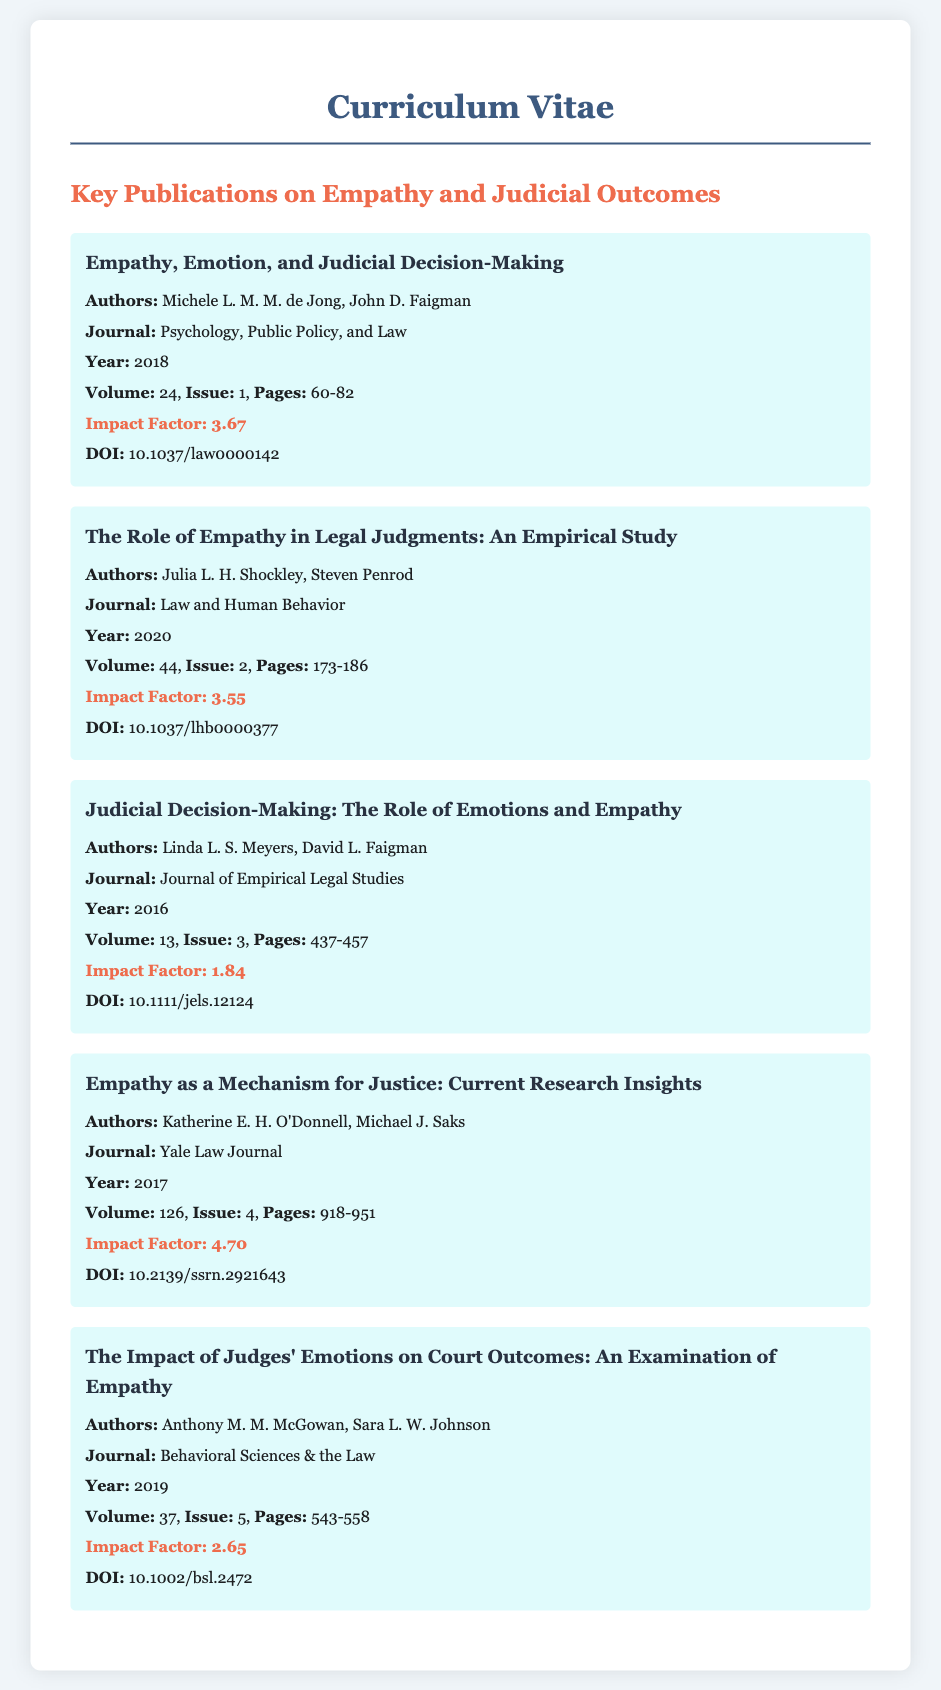What is the title of the first publication listed? The title of the first publication is given in the document under "Key Publications on Empathy and Judicial Outcomes."
Answer: Empathy, Emotion, and Judicial Decision-Making Who are the authors of "The Role of Empathy in Legal Judgments: An Empirical Study"? The authors are listed directly under the title of the publication, providing the necessary details.
Answer: Julia L. H. Shockley, Steven Penrod What is the impact factor of the publication "Empathy as a Mechanism for Justice: Current Research Insights"? The impact factor is highlighted in the document, making it easy to retrieve this specific data.
Answer: 4.70 In which year was "Judicial Decision-Making: The Role of Emotions and Empathy" published? The year of publication is explicitly stated next to each publication in the document.
Answer: 2016 How many publications listed have an impact factor greater than 3.5? To answer, one must count the number of publications with impact factors exceeding 3.5 from the given information.
Answer: 3 What is the journal name for the publication authored by Linda L. S. Meyers and David L. Faigman? The journal name is specifically mentioned alongside each publication title.
Answer: Journal of Empirical Legal Studies What is the volume number of "The Impact of Judges' Emotions on Court Outcomes: An Examination of Empathy"? The volume number is listed in the same section as the publication's details.
Answer: 37 